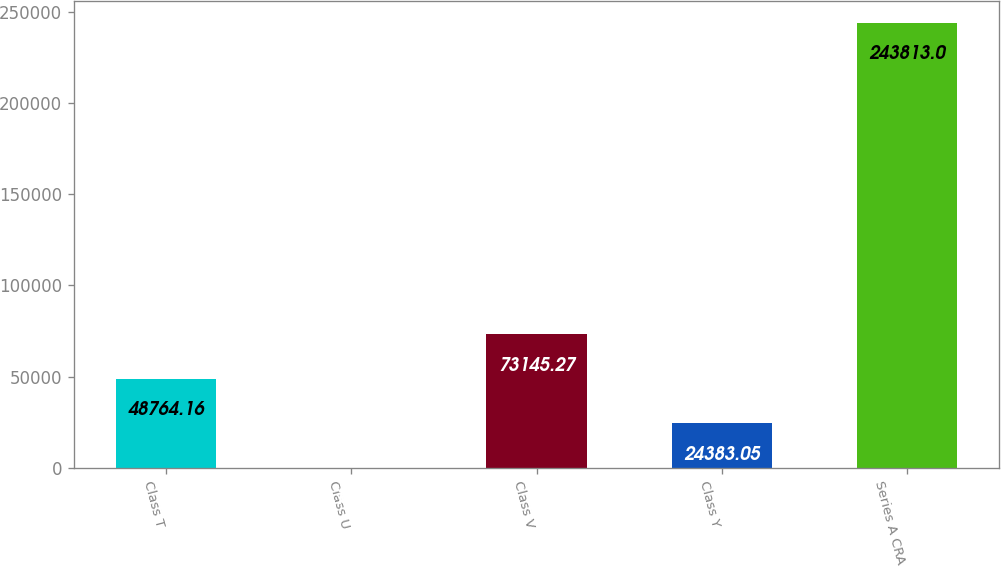Convert chart. <chart><loc_0><loc_0><loc_500><loc_500><bar_chart><fcel>Class T<fcel>Class U<fcel>Class V<fcel>Class Y<fcel>Series A CRA<nl><fcel>48764.2<fcel>1.94<fcel>73145.3<fcel>24383<fcel>243813<nl></chart> 